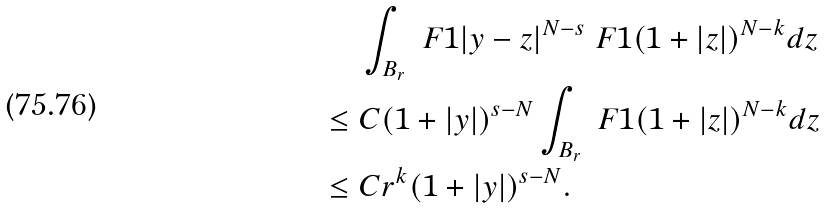Convert formula to latex. <formula><loc_0><loc_0><loc_500><loc_500>& \ \int _ { B _ { r } } \ F { 1 } { | y - z | ^ { N - s } } \ F { 1 } { ( 1 + | z | ) ^ { N - k } } d z \\ \leq & \ C ( 1 + | y | ) ^ { s - N } \int _ { B _ { r } } \ F { 1 } { ( 1 + | z | ) ^ { N - k } } d z \\ \leq & \ C r ^ { k } ( 1 + | y | ) ^ { s - N } .</formula> 